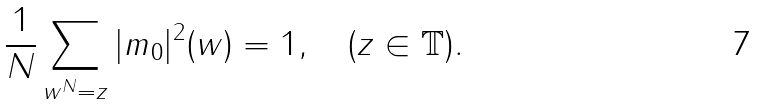<formula> <loc_0><loc_0><loc_500><loc_500>\frac { 1 } { N } \sum _ { w ^ { N } = z } | m _ { 0 } | ^ { 2 } ( w ) = 1 , \quad ( z \in \mathbb { T } ) .</formula> 